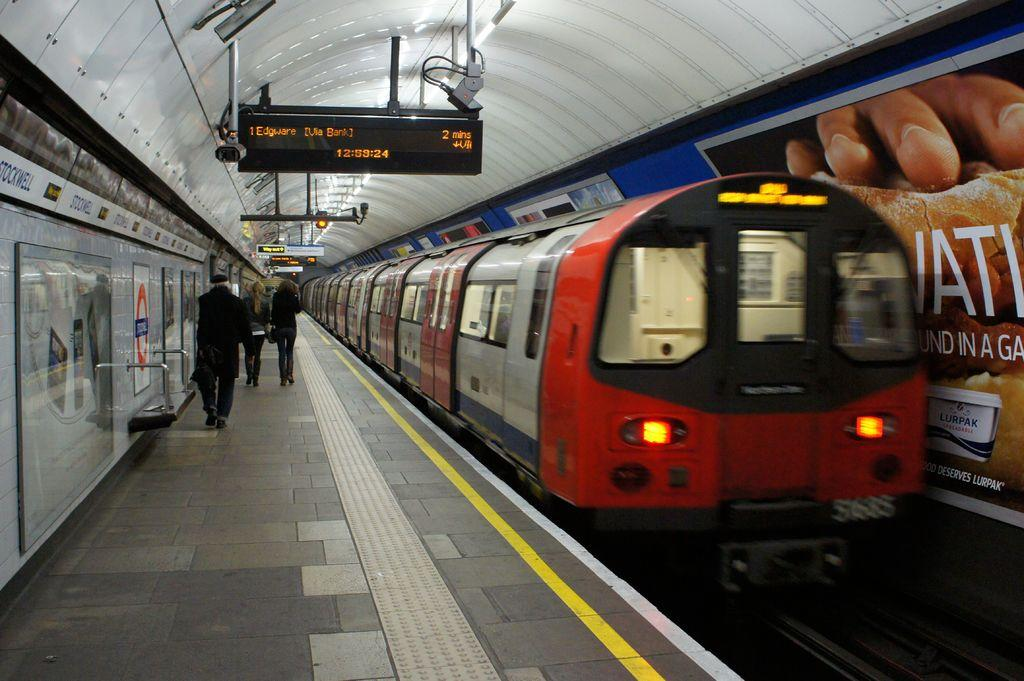What type of vehicles can be seen on the tracks in the image? There are trains on the tracks in the image. What are the people in the image doing? There are persons walking on the platforms in the image. What type of information is displayed in the image? Name boards and sign boards are visible in the image. What else can be seen in the image besides the trains and people? Advertisements are present in the image. What safety feature is visible in the image? Signal lights are visible in the image. What type of waste can be seen on the tracks in the image? There is no waste visible on the tracks in the image. How many passengers are visible in the image? The number of passengers cannot be determined from the image, as it only shows people walking on the platforms, not boarding or disembarking from the trains. 